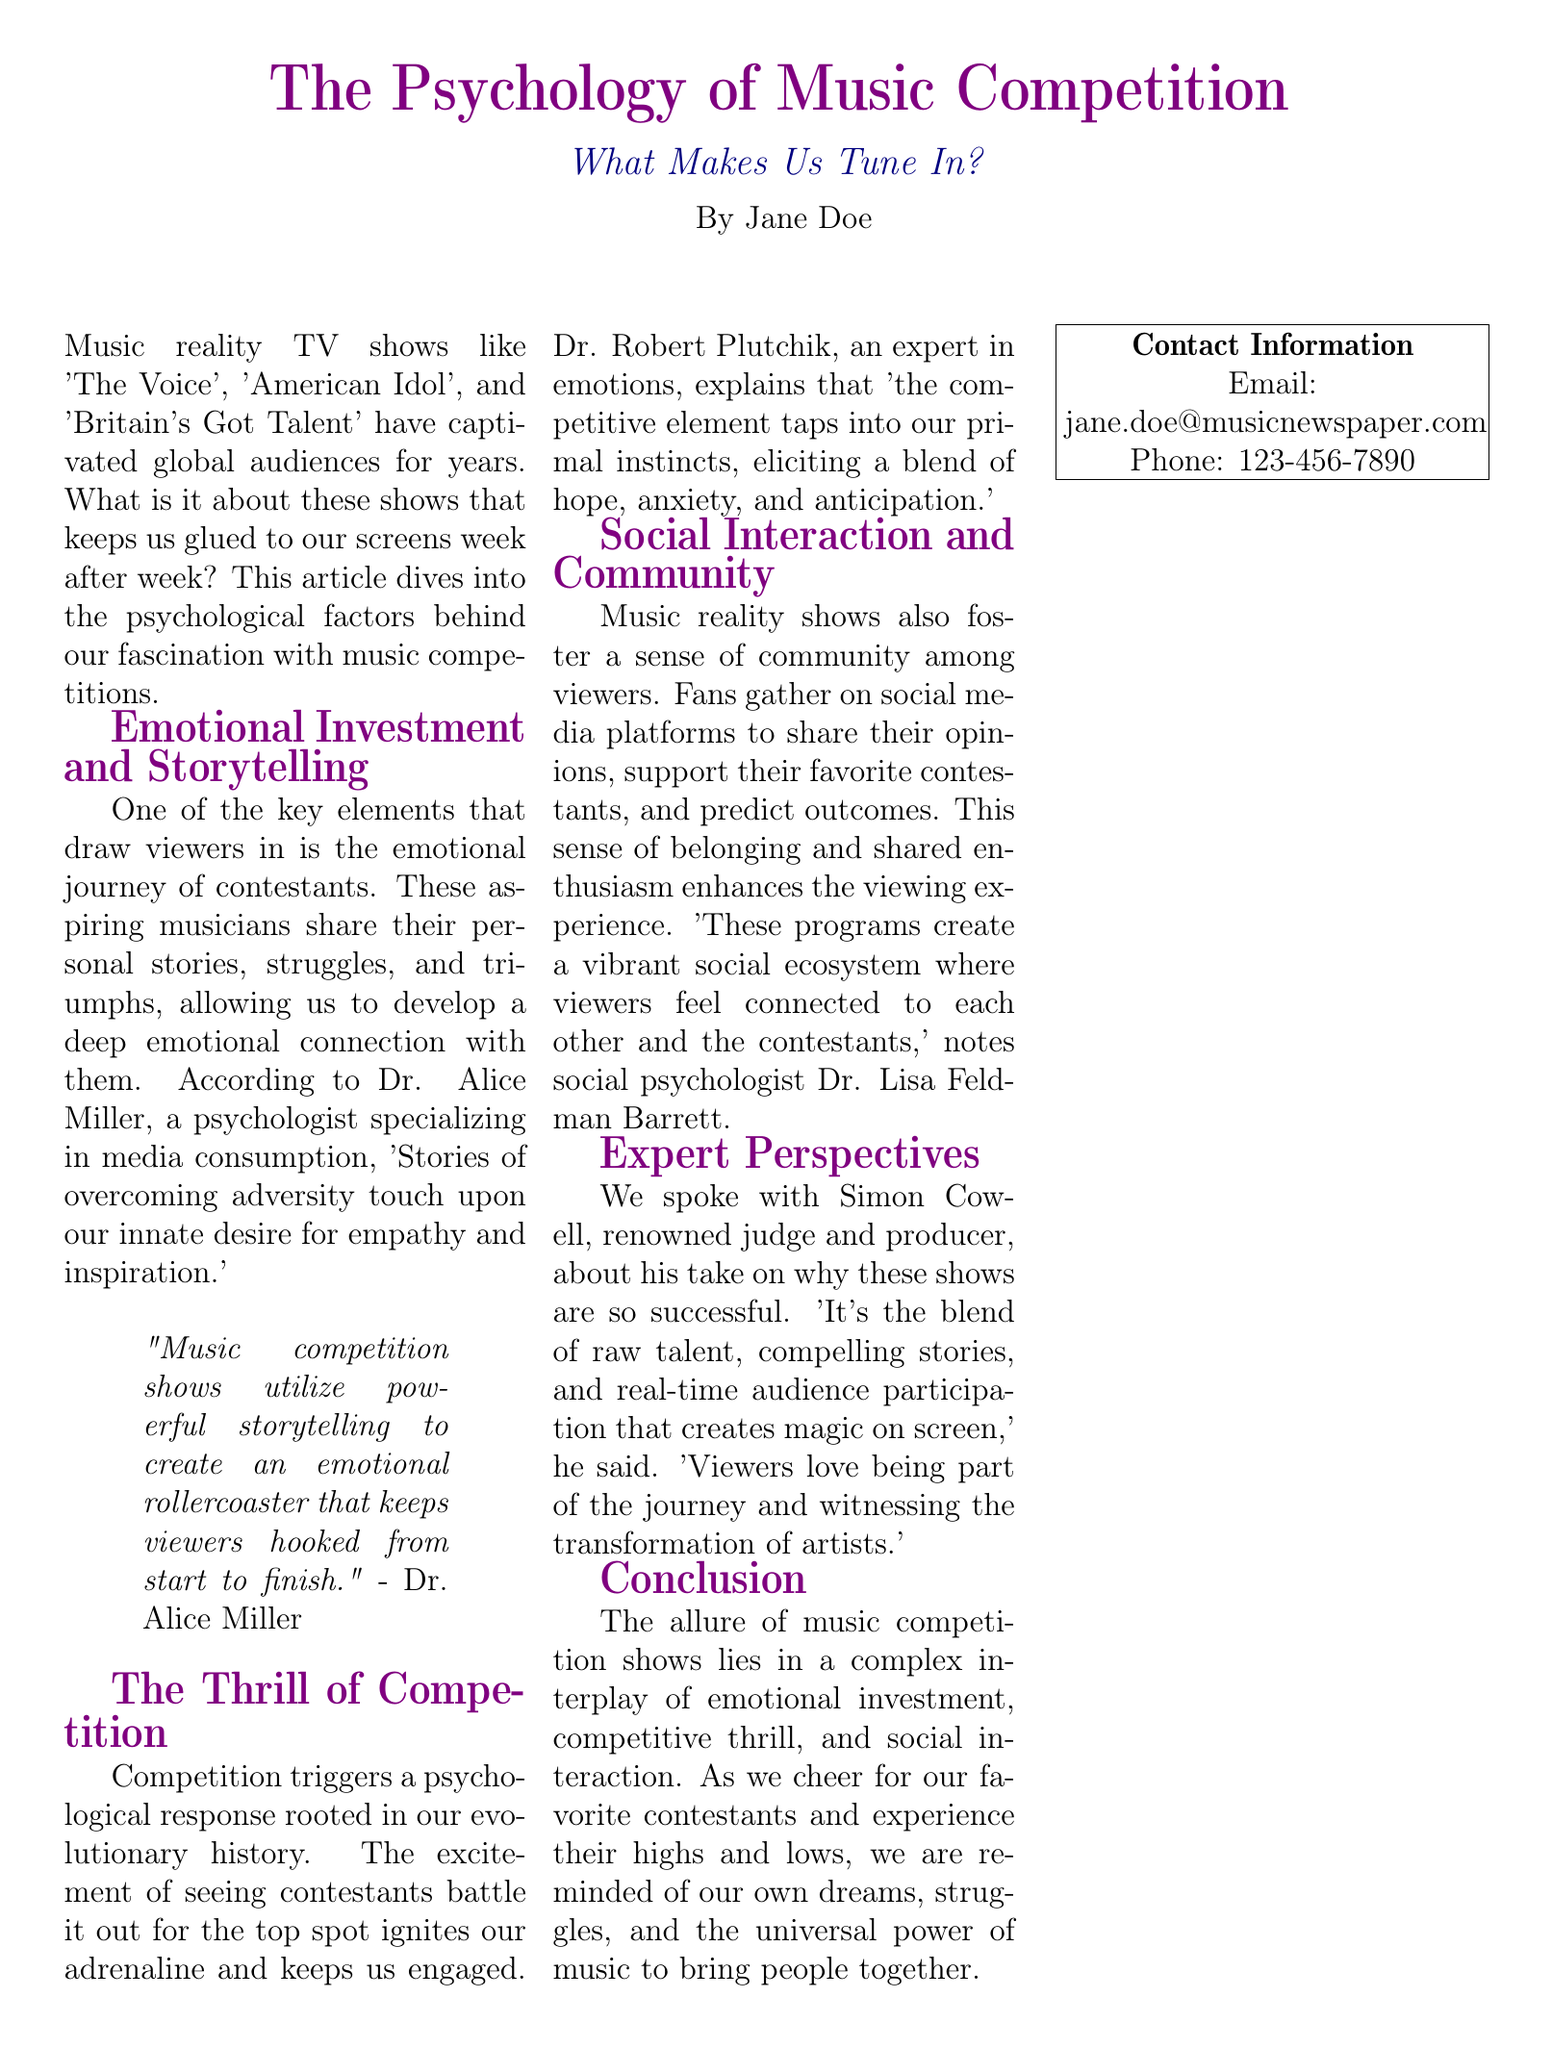What are some popular music reality TV shows mentioned? The document lists specific shows that have captivated audiences including 'The Voice', 'American Idol', and 'Britain's Got Talent'.
Answer: 'The Voice', 'American Idol', 'Britain's Got Talent' Who is Dr. Alice Miller? The document describes Dr. Alice Miller as a psychologist specializing in media consumption.
Answer: a psychologist specializing in media consumption What does Dr. Robert Plutchik explain competition evokes? Dr. Robert Plutchik discusses the psychological response elicited by competition, mentioning a blend of hope, anxiety, and anticipation.
Answer: hope, anxiety, and anticipation According to the article, how do music competition shows affect social interaction? The document suggests that viewers gather on social media platforms to share opinions and support contestants, enhancing the viewing experience.
Answer: Create a vibrant social ecosystem What is Simon Cowell's role in music competition shows? The article states that Simon Cowell is a renowned judge and producer in the music competition show industry.
Answer: judge and producer What is the main theme discussed in the conclusion? The conclusion highlights the complex interplay of emotional investment, competitive thrill, and social interaction in music competition shows.
Answer: emotional investment, competitive thrill, and social interaction What was used to accompany the expert interviews in the article? The document mentions striking visual elements like brain diagrams and emotional spectrum graphs were used alongside expert interviews.
Answer: brain diagrams and emotional spectrum graphs Who is Dr. Lisa Feldman Barrett? The document identifies Dr. Lisa Feldman Barrett as a social psychologist who comments on the community aspect of music reality shows.
Answer: a social psychologist What is the publication date of the article? The article does not provide a specific date of publication.
Answer: Not mentioned 